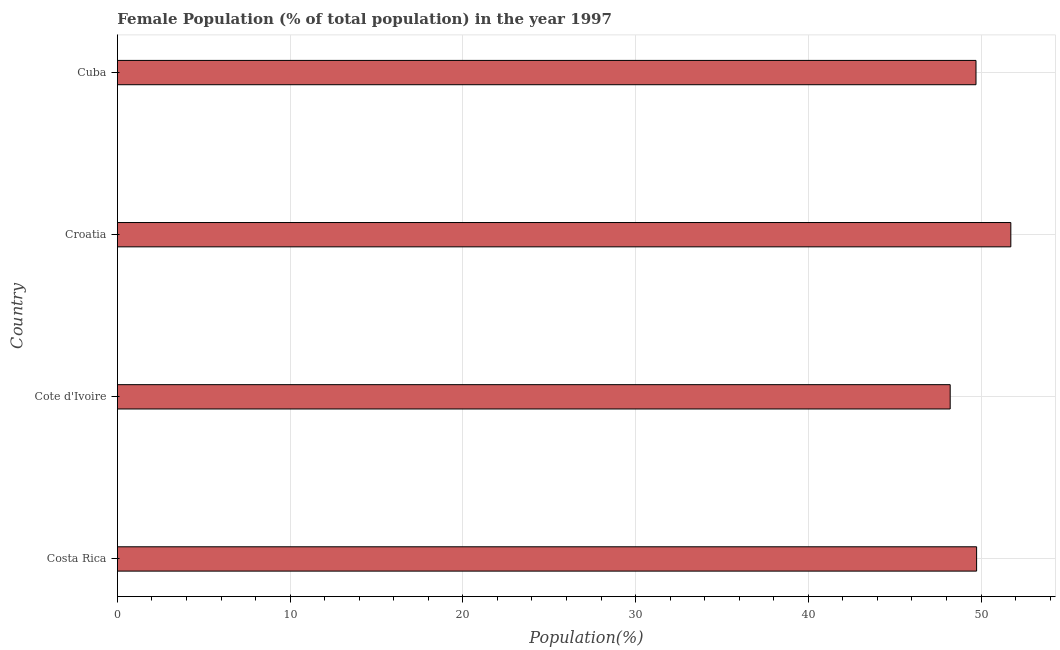What is the title of the graph?
Your answer should be very brief. Female Population (% of total population) in the year 1997. What is the label or title of the X-axis?
Provide a succinct answer. Population(%). What is the label or title of the Y-axis?
Your answer should be very brief. Country. What is the female population in Cote d'Ivoire?
Your answer should be very brief. 48.22. Across all countries, what is the maximum female population?
Provide a succinct answer. 51.73. Across all countries, what is the minimum female population?
Give a very brief answer. 48.22. In which country was the female population maximum?
Keep it short and to the point. Croatia. In which country was the female population minimum?
Provide a short and direct response. Cote d'Ivoire. What is the sum of the female population?
Give a very brief answer. 199.4. What is the difference between the female population in Costa Rica and Cuba?
Your response must be concise. 0.04. What is the average female population per country?
Offer a terse response. 49.85. What is the median female population?
Your answer should be compact. 49.73. What is the ratio of the female population in Croatia to that in Cuba?
Give a very brief answer. 1.04. Is the difference between the female population in Costa Rica and Cote d'Ivoire greater than the difference between any two countries?
Your response must be concise. No. What is the difference between the highest and the second highest female population?
Provide a short and direct response. 1.98. What is the difference between the highest and the lowest female population?
Provide a short and direct response. 3.51. In how many countries, is the female population greater than the average female population taken over all countries?
Offer a terse response. 1. How many bars are there?
Your answer should be compact. 4. Are all the bars in the graph horizontal?
Keep it short and to the point. Yes. What is the Population(%) in Costa Rica?
Ensure brevity in your answer.  49.75. What is the Population(%) in Cote d'Ivoire?
Your answer should be very brief. 48.22. What is the Population(%) in Croatia?
Keep it short and to the point. 51.73. What is the Population(%) in Cuba?
Your answer should be compact. 49.71. What is the difference between the Population(%) in Costa Rica and Cote d'Ivoire?
Give a very brief answer. 1.53. What is the difference between the Population(%) in Costa Rica and Croatia?
Offer a very short reply. -1.98. What is the difference between the Population(%) in Costa Rica and Cuba?
Keep it short and to the point. 0.04. What is the difference between the Population(%) in Cote d'Ivoire and Croatia?
Make the answer very short. -3.51. What is the difference between the Population(%) in Cote d'Ivoire and Cuba?
Keep it short and to the point. -1.49. What is the difference between the Population(%) in Croatia and Cuba?
Make the answer very short. 2.02. What is the ratio of the Population(%) in Costa Rica to that in Cote d'Ivoire?
Provide a succinct answer. 1.03. What is the ratio of the Population(%) in Costa Rica to that in Cuba?
Offer a terse response. 1. What is the ratio of the Population(%) in Cote d'Ivoire to that in Croatia?
Provide a short and direct response. 0.93. What is the ratio of the Population(%) in Croatia to that in Cuba?
Ensure brevity in your answer.  1.04. 